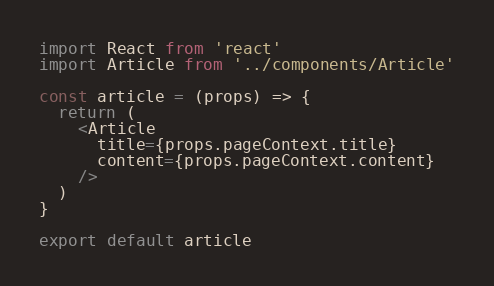Convert code to text. <code><loc_0><loc_0><loc_500><loc_500><_JavaScript_>import React from 'react'
import Article from '../components/Article'

const article = (props) => {
  return (
    <Article
      title={props.pageContext.title}
      content={props.pageContext.content}
    />
  )
}

export default article
</code> 